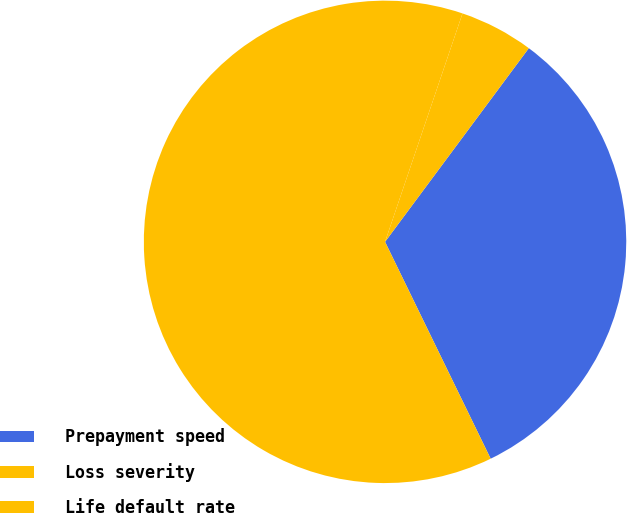Convert chart. <chart><loc_0><loc_0><loc_500><loc_500><pie_chart><fcel>Prepayment speed<fcel>Loss severity<fcel>Life default rate<nl><fcel>32.62%<fcel>62.41%<fcel>4.96%<nl></chart> 